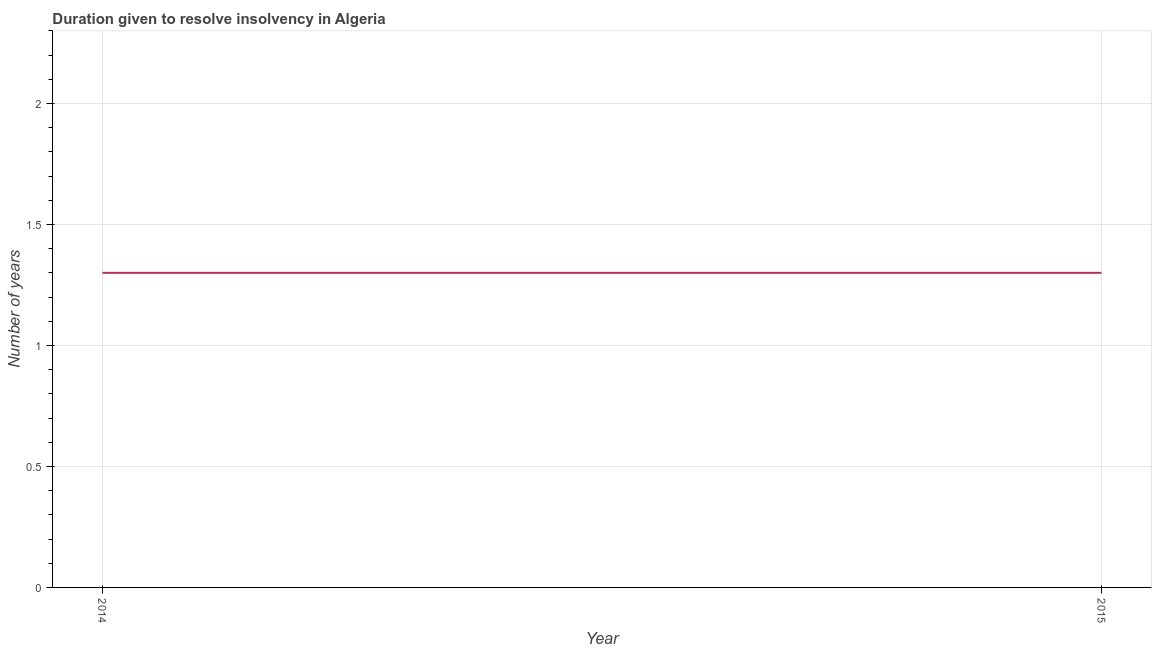What is the number of years to resolve insolvency in 2014?
Your answer should be very brief. 1.3. Across all years, what is the minimum number of years to resolve insolvency?
Provide a succinct answer. 1.3. In which year was the number of years to resolve insolvency maximum?
Keep it short and to the point. 2014. In which year was the number of years to resolve insolvency minimum?
Ensure brevity in your answer.  2014. What is the sum of the number of years to resolve insolvency?
Your answer should be compact. 2.6. What is the difference between the number of years to resolve insolvency in 2014 and 2015?
Keep it short and to the point. 0. Do a majority of the years between 2015 and 2014 (inclusive) have number of years to resolve insolvency greater than 0.1 ?
Your response must be concise. No. What is the ratio of the number of years to resolve insolvency in 2014 to that in 2015?
Give a very brief answer. 1. Is the number of years to resolve insolvency in 2014 less than that in 2015?
Your answer should be compact. No. How many lines are there?
Offer a terse response. 1. What is the difference between two consecutive major ticks on the Y-axis?
Provide a short and direct response. 0.5. Does the graph contain any zero values?
Your answer should be very brief. No. Does the graph contain grids?
Your answer should be very brief. Yes. What is the title of the graph?
Ensure brevity in your answer.  Duration given to resolve insolvency in Algeria. What is the label or title of the X-axis?
Your answer should be compact. Year. What is the label or title of the Y-axis?
Make the answer very short. Number of years. What is the Number of years in 2014?
Keep it short and to the point. 1.3. 